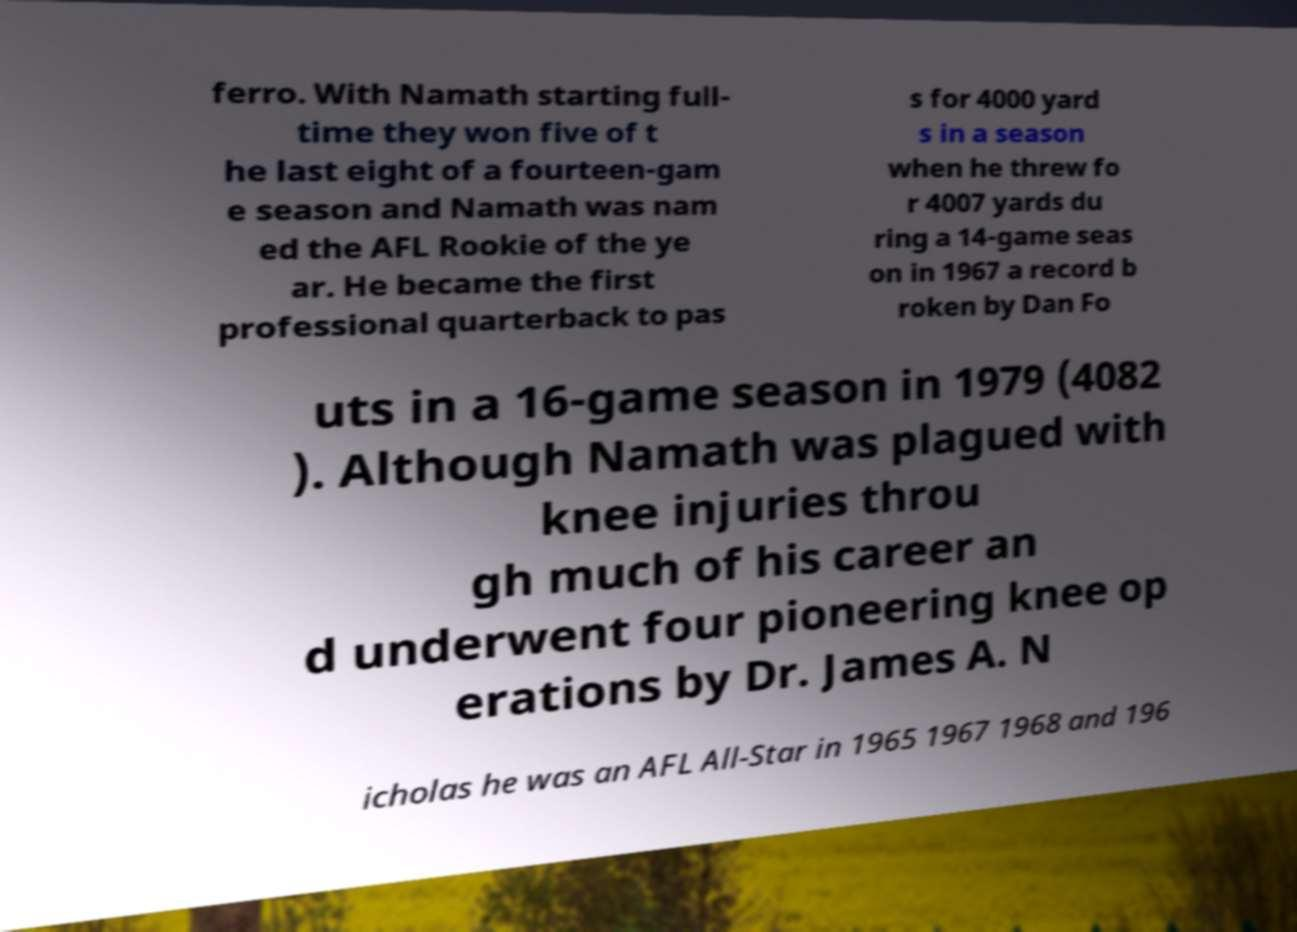I need the written content from this picture converted into text. Can you do that? ferro. With Namath starting full- time they won five of t he last eight of a fourteen-gam e season and Namath was nam ed the AFL Rookie of the ye ar. He became the first professional quarterback to pas s for 4000 yard s in a season when he threw fo r 4007 yards du ring a 14-game seas on in 1967 a record b roken by Dan Fo uts in a 16-game season in 1979 (4082 ). Although Namath was plagued with knee injuries throu gh much of his career an d underwent four pioneering knee op erations by Dr. James A. N icholas he was an AFL All-Star in 1965 1967 1968 and 196 